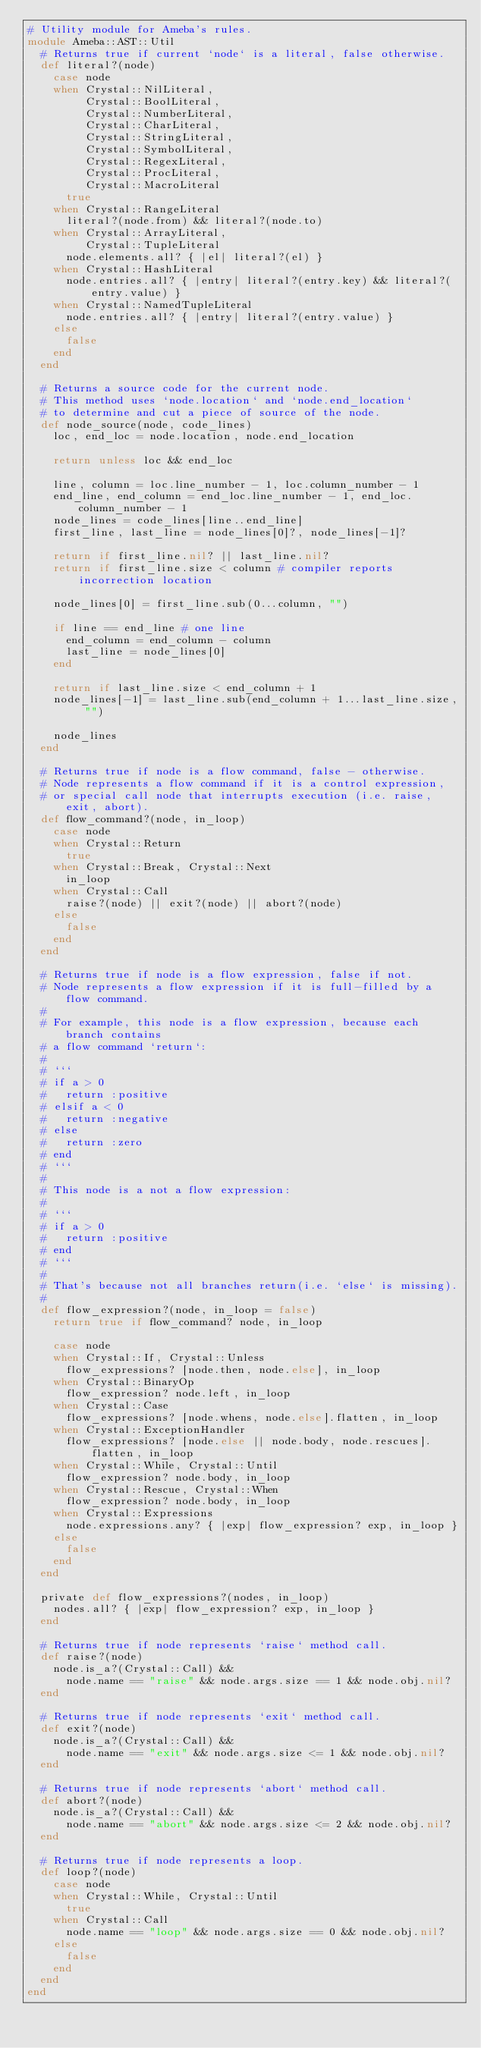<code> <loc_0><loc_0><loc_500><loc_500><_Crystal_># Utility module for Ameba's rules.
module Ameba::AST::Util
  # Returns true if current `node` is a literal, false otherwise.
  def literal?(node)
    case node
    when Crystal::NilLiteral,
         Crystal::BoolLiteral,
         Crystal::NumberLiteral,
         Crystal::CharLiteral,
         Crystal::StringLiteral,
         Crystal::SymbolLiteral,
         Crystal::RegexLiteral,
         Crystal::ProcLiteral,
         Crystal::MacroLiteral
      true
    when Crystal::RangeLiteral
      literal?(node.from) && literal?(node.to)
    when Crystal::ArrayLiteral,
         Crystal::TupleLiteral
      node.elements.all? { |el| literal?(el) }
    when Crystal::HashLiteral
      node.entries.all? { |entry| literal?(entry.key) && literal?(entry.value) }
    when Crystal::NamedTupleLiteral
      node.entries.all? { |entry| literal?(entry.value) }
    else
      false
    end
  end

  # Returns a source code for the current node.
  # This method uses `node.location` and `node.end_location`
  # to determine and cut a piece of source of the node.
  def node_source(node, code_lines)
    loc, end_loc = node.location, node.end_location

    return unless loc && end_loc

    line, column = loc.line_number - 1, loc.column_number - 1
    end_line, end_column = end_loc.line_number - 1, end_loc.column_number - 1
    node_lines = code_lines[line..end_line]
    first_line, last_line = node_lines[0]?, node_lines[-1]?

    return if first_line.nil? || last_line.nil?
    return if first_line.size < column # compiler reports incorrection location

    node_lines[0] = first_line.sub(0...column, "")

    if line == end_line # one line
      end_column = end_column - column
      last_line = node_lines[0]
    end

    return if last_line.size < end_column + 1
    node_lines[-1] = last_line.sub(end_column + 1...last_line.size, "")

    node_lines
  end

  # Returns true if node is a flow command, false - otherwise.
  # Node represents a flow command if it is a control expression,
  # or special call node that interrupts execution (i.e. raise, exit, abort).
  def flow_command?(node, in_loop)
    case node
    when Crystal::Return
      true
    when Crystal::Break, Crystal::Next
      in_loop
    when Crystal::Call
      raise?(node) || exit?(node) || abort?(node)
    else
      false
    end
  end

  # Returns true if node is a flow expression, false if not.
  # Node represents a flow expression if it is full-filled by a flow command.
  #
  # For example, this node is a flow expression, because each branch contains
  # a flow command `return`:
  #
  # ```
  # if a > 0
  #   return :positive
  # elsif a < 0
  #   return :negative
  # else
  #   return :zero
  # end
  # ```
  #
  # This node is a not a flow expression:
  #
  # ```
  # if a > 0
  #   return :positive
  # end
  # ```
  #
  # That's because not all branches return(i.e. `else` is missing).
  #
  def flow_expression?(node, in_loop = false)
    return true if flow_command? node, in_loop

    case node
    when Crystal::If, Crystal::Unless
      flow_expressions? [node.then, node.else], in_loop
    when Crystal::BinaryOp
      flow_expression? node.left, in_loop
    when Crystal::Case
      flow_expressions? [node.whens, node.else].flatten, in_loop
    when Crystal::ExceptionHandler
      flow_expressions? [node.else || node.body, node.rescues].flatten, in_loop
    when Crystal::While, Crystal::Until
      flow_expression? node.body, in_loop
    when Crystal::Rescue, Crystal::When
      flow_expression? node.body, in_loop
    when Crystal::Expressions
      node.expressions.any? { |exp| flow_expression? exp, in_loop }
    else
      false
    end
  end

  private def flow_expressions?(nodes, in_loop)
    nodes.all? { |exp| flow_expression? exp, in_loop }
  end

  # Returns true if node represents `raise` method call.
  def raise?(node)
    node.is_a?(Crystal::Call) &&
      node.name == "raise" && node.args.size == 1 && node.obj.nil?
  end

  # Returns true if node represents `exit` method call.
  def exit?(node)
    node.is_a?(Crystal::Call) &&
      node.name == "exit" && node.args.size <= 1 && node.obj.nil?
  end

  # Returns true if node represents `abort` method call.
  def abort?(node)
    node.is_a?(Crystal::Call) &&
      node.name == "abort" && node.args.size <= 2 && node.obj.nil?
  end

  # Returns true if node represents a loop.
  def loop?(node)
    case node
    when Crystal::While, Crystal::Until
      true
    when Crystal::Call
      node.name == "loop" && node.args.size == 0 && node.obj.nil?
    else
      false
    end
  end
end
</code> 